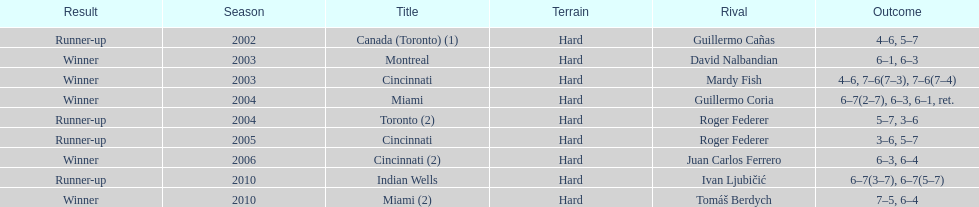Can you give me this table as a dict? {'header': ['Result', 'Season', 'Title', 'Terrain', 'Rival', 'Outcome'], 'rows': [['Runner-up', '2002', 'Canada (Toronto) (1)', 'Hard', 'Guillermo Cañas', '4–6, 5–7'], ['Winner', '2003', 'Montreal', 'Hard', 'David Nalbandian', '6–1, 6–3'], ['Winner', '2003', 'Cincinnati', 'Hard', 'Mardy Fish', '4–6, 7–6(7–3), 7–6(7–4)'], ['Winner', '2004', 'Miami', 'Hard', 'Guillermo Coria', '6–7(2–7), 6–3, 6–1, ret.'], ['Runner-up', '2004', 'Toronto (2)', 'Hard', 'Roger Federer', '5–7, 3–6'], ['Runner-up', '2005', 'Cincinnati', 'Hard', 'Roger Federer', '3–6, 5–7'], ['Winner', '2006', 'Cincinnati (2)', 'Hard', 'Juan Carlos Ferrero', '6–3, 6–4'], ['Runner-up', '2010', 'Indian Wells', 'Hard', 'Ivan Ljubičić', '6–7(3–7), 6–7(5–7)'], ['Winner', '2010', 'Miami (2)', 'Hard', 'Tomáš Berdych', '7–5, 6–4']]} How many championships occurred in toronto or montreal? 3. 